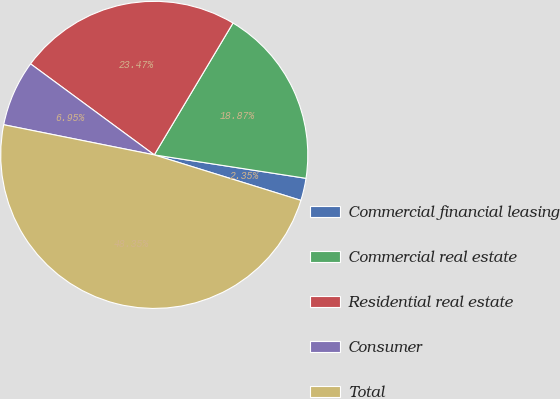Convert chart to OTSL. <chart><loc_0><loc_0><loc_500><loc_500><pie_chart><fcel>Commercial financial leasing<fcel>Commercial real estate<fcel>Residential real estate<fcel>Consumer<fcel>Total<nl><fcel>2.35%<fcel>18.87%<fcel>23.47%<fcel>6.95%<fcel>48.35%<nl></chart> 